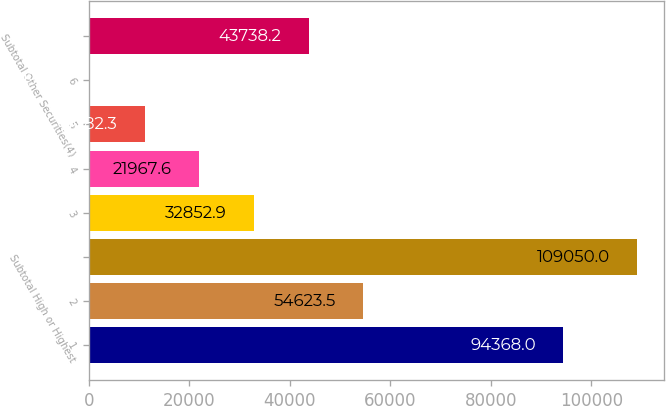Convert chart to OTSL. <chart><loc_0><loc_0><loc_500><loc_500><bar_chart><fcel>1<fcel>2<fcel>Subtotal High or Highest<fcel>3<fcel>4<fcel>5<fcel>6<fcel>Subtotal Other Securities(4)<nl><fcel>94368<fcel>54623.5<fcel>109050<fcel>32852.9<fcel>21967.6<fcel>11082.3<fcel>197<fcel>43738.2<nl></chart> 